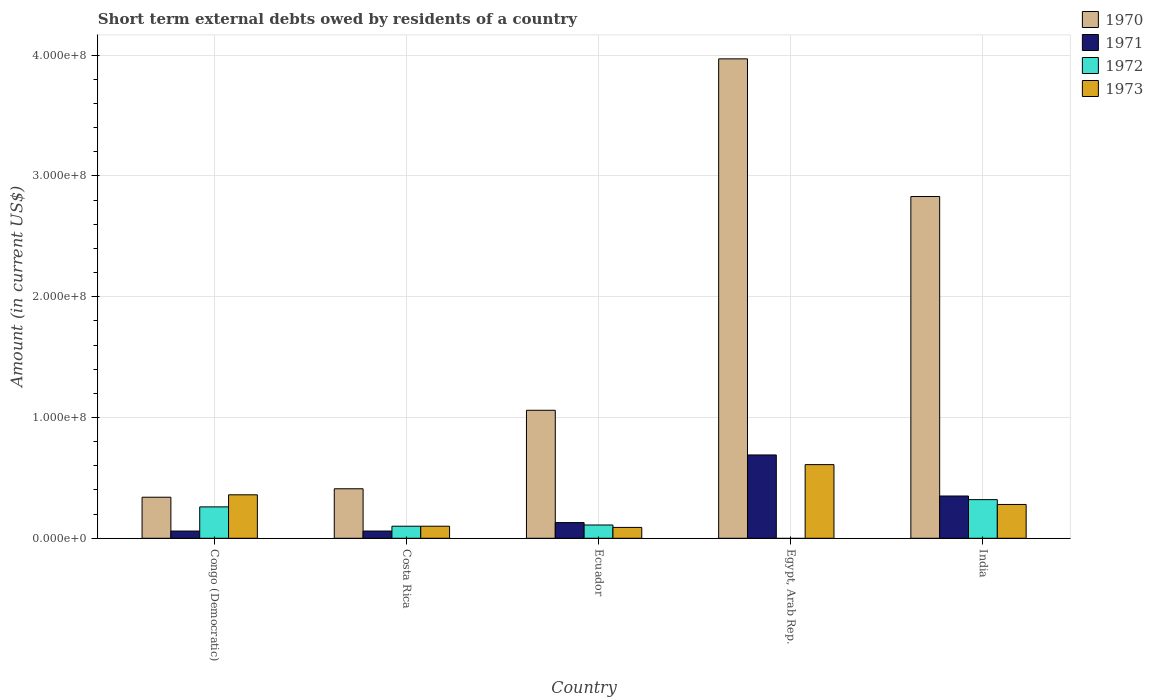How many different coloured bars are there?
Keep it short and to the point. 4. Are the number of bars per tick equal to the number of legend labels?
Give a very brief answer. No. What is the label of the 4th group of bars from the left?
Provide a short and direct response. Egypt, Arab Rep. What is the amount of short-term external debts owed by residents in 1973 in India?
Make the answer very short. 2.80e+07. Across all countries, what is the maximum amount of short-term external debts owed by residents in 1973?
Your answer should be compact. 6.10e+07. Across all countries, what is the minimum amount of short-term external debts owed by residents in 1970?
Keep it short and to the point. 3.40e+07. In which country was the amount of short-term external debts owed by residents in 1971 maximum?
Make the answer very short. Egypt, Arab Rep. What is the total amount of short-term external debts owed by residents in 1970 in the graph?
Your response must be concise. 8.61e+08. What is the difference between the amount of short-term external debts owed by residents in 1970 in Costa Rica and that in Egypt, Arab Rep.?
Provide a short and direct response. -3.56e+08. What is the difference between the amount of short-term external debts owed by residents in 1973 in India and the amount of short-term external debts owed by residents in 1971 in Ecuador?
Keep it short and to the point. 1.50e+07. What is the average amount of short-term external debts owed by residents in 1973 per country?
Your response must be concise. 2.88e+07. In how many countries, is the amount of short-term external debts owed by residents in 1972 greater than 380000000 US$?
Ensure brevity in your answer.  0. What is the ratio of the amount of short-term external debts owed by residents in 1972 in Ecuador to that in India?
Make the answer very short. 0.34. Is the amount of short-term external debts owed by residents in 1970 in Ecuador less than that in Egypt, Arab Rep.?
Your answer should be compact. Yes. What is the difference between the highest and the lowest amount of short-term external debts owed by residents in 1970?
Your answer should be compact. 3.63e+08. Is the sum of the amount of short-term external debts owed by residents in 1973 in Egypt, Arab Rep. and India greater than the maximum amount of short-term external debts owed by residents in 1972 across all countries?
Your answer should be very brief. Yes. Is it the case that in every country, the sum of the amount of short-term external debts owed by residents in 1970 and amount of short-term external debts owed by residents in 1971 is greater than the sum of amount of short-term external debts owed by residents in 1972 and amount of short-term external debts owed by residents in 1973?
Give a very brief answer. Yes. Is it the case that in every country, the sum of the amount of short-term external debts owed by residents in 1973 and amount of short-term external debts owed by residents in 1971 is greater than the amount of short-term external debts owed by residents in 1970?
Offer a terse response. No. How many countries are there in the graph?
Provide a short and direct response. 5. What is the difference between two consecutive major ticks on the Y-axis?
Give a very brief answer. 1.00e+08. Where does the legend appear in the graph?
Offer a very short reply. Top right. How are the legend labels stacked?
Provide a short and direct response. Vertical. What is the title of the graph?
Make the answer very short. Short term external debts owed by residents of a country. Does "2005" appear as one of the legend labels in the graph?
Provide a succinct answer. No. What is the Amount (in current US$) of 1970 in Congo (Democratic)?
Provide a short and direct response. 3.40e+07. What is the Amount (in current US$) of 1971 in Congo (Democratic)?
Offer a terse response. 6.00e+06. What is the Amount (in current US$) of 1972 in Congo (Democratic)?
Provide a succinct answer. 2.60e+07. What is the Amount (in current US$) of 1973 in Congo (Democratic)?
Offer a terse response. 3.60e+07. What is the Amount (in current US$) in 1970 in Costa Rica?
Keep it short and to the point. 4.10e+07. What is the Amount (in current US$) in 1972 in Costa Rica?
Your answer should be compact. 1.00e+07. What is the Amount (in current US$) in 1973 in Costa Rica?
Your answer should be very brief. 1.00e+07. What is the Amount (in current US$) of 1970 in Ecuador?
Your response must be concise. 1.06e+08. What is the Amount (in current US$) in 1971 in Ecuador?
Provide a short and direct response. 1.30e+07. What is the Amount (in current US$) of 1972 in Ecuador?
Your answer should be compact. 1.10e+07. What is the Amount (in current US$) of 1973 in Ecuador?
Your response must be concise. 9.00e+06. What is the Amount (in current US$) in 1970 in Egypt, Arab Rep.?
Your answer should be very brief. 3.97e+08. What is the Amount (in current US$) in 1971 in Egypt, Arab Rep.?
Ensure brevity in your answer.  6.90e+07. What is the Amount (in current US$) in 1973 in Egypt, Arab Rep.?
Offer a terse response. 6.10e+07. What is the Amount (in current US$) of 1970 in India?
Make the answer very short. 2.83e+08. What is the Amount (in current US$) of 1971 in India?
Make the answer very short. 3.50e+07. What is the Amount (in current US$) in 1972 in India?
Provide a succinct answer. 3.20e+07. What is the Amount (in current US$) of 1973 in India?
Your response must be concise. 2.80e+07. Across all countries, what is the maximum Amount (in current US$) of 1970?
Provide a succinct answer. 3.97e+08. Across all countries, what is the maximum Amount (in current US$) of 1971?
Provide a succinct answer. 6.90e+07. Across all countries, what is the maximum Amount (in current US$) of 1972?
Your response must be concise. 3.20e+07. Across all countries, what is the maximum Amount (in current US$) in 1973?
Make the answer very short. 6.10e+07. Across all countries, what is the minimum Amount (in current US$) in 1970?
Give a very brief answer. 3.40e+07. Across all countries, what is the minimum Amount (in current US$) of 1972?
Offer a terse response. 0. Across all countries, what is the minimum Amount (in current US$) of 1973?
Keep it short and to the point. 9.00e+06. What is the total Amount (in current US$) of 1970 in the graph?
Keep it short and to the point. 8.61e+08. What is the total Amount (in current US$) in 1971 in the graph?
Your response must be concise. 1.29e+08. What is the total Amount (in current US$) of 1972 in the graph?
Make the answer very short. 7.90e+07. What is the total Amount (in current US$) of 1973 in the graph?
Offer a very short reply. 1.44e+08. What is the difference between the Amount (in current US$) of 1970 in Congo (Democratic) and that in Costa Rica?
Provide a succinct answer. -7.00e+06. What is the difference between the Amount (in current US$) in 1972 in Congo (Democratic) and that in Costa Rica?
Provide a short and direct response. 1.60e+07. What is the difference between the Amount (in current US$) in 1973 in Congo (Democratic) and that in Costa Rica?
Your answer should be very brief. 2.60e+07. What is the difference between the Amount (in current US$) in 1970 in Congo (Democratic) and that in Ecuador?
Keep it short and to the point. -7.20e+07. What is the difference between the Amount (in current US$) in 1971 in Congo (Democratic) and that in Ecuador?
Give a very brief answer. -7.00e+06. What is the difference between the Amount (in current US$) of 1972 in Congo (Democratic) and that in Ecuador?
Ensure brevity in your answer.  1.50e+07. What is the difference between the Amount (in current US$) of 1973 in Congo (Democratic) and that in Ecuador?
Your answer should be very brief. 2.70e+07. What is the difference between the Amount (in current US$) of 1970 in Congo (Democratic) and that in Egypt, Arab Rep.?
Provide a short and direct response. -3.63e+08. What is the difference between the Amount (in current US$) of 1971 in Congo (Democratic) and that in Egypt, Arab Rep.?
Keep it short and to the point. -6.30e+07. What is the difference between the Amount (in current US$) in 1973 in Congo (Democratic) and that in Egypt, Arab Rep.?
Keep it short and to the point. -2.50e+07. What is the difference between the Amount (in current US$) in 1970 in Congo (Democratic) and that in India?
Your response must be concise. -2.49e+08. What is the difference between the Amount (in current US$) of 1971 in Congo (Democratic) and that in India?
Offer a very short reply. -2.90e+07. What is the difference between the Amount (in current US$) of 1972 in Congo (Democratic) and that in India?
Give a very brief answer. -6.00e+06. What is the difference between the Amount (in current US$) of 1970 in Costa Rica and that in Ecuador?
Offer a very short reply. -6.50e+07. What is the difference between the Amount (in current US$) of 1971 in Costa Rica and that in Ecuador?
Offer a terse response. -7.00e+06. What is the difference between the Amount (in current US$) of 1970 in Costa Rica and that in Egypt, Arab Rep.?
Ensure brevity in your answer.  -3.56e+08. What is the difference between the Amount (in current US$) in 1971 in Costa Rica and that in Egypt, Arab Rep.?
Offer a terse response. -6.30e+07. What is the difference between the Amount (in current US$) in 1973 in Costa Rica and that in Egypt, Arab Rep.?
Make the answer very short. -5.10e+07. What is the difference between the Amount (in current US$) of 1970 in Costa Rica and that in India?
Offer a terse response. -2.42e+08. What is the difference between the Amount (in current US$) in 1971 in Costa Rica and that in India?
Give a very brief answer. -2.90e+07. What is the difference between the Amount (in current US$) in 1972 in Costa Rica and that in India?
Your answer should be compact. -2.20e+07. What is the difference between the Amount (in current US$) of 1973 in Costa Rica and that in India?
Your answer should be compact. -1.80e+07. What is the difference between the Amount (in current US$) in 1970 in Ecuador and that in Egypt, Arab Rep.?
Provide a succinct answer. -2.91e+08. What is the difference between the Amount (in current US$) in 1971 in Ecuador and that in Egypt, Arab Rep.?
Offer a very short reply. -5.60e+07. What is the difference between the Amount (in current US$) in 1973 in Ecuador and that in Egypt, Arab Rep.?
Ensure brevity in your answer.  -5.20e+07. What is the difference between the Amount (in current US$) in 1970 in Ecuador and that in India?
Ensure brevity in your answer.  -1.77e+08. What is the difference between the Amount (in current US$) of 1971 in Ecuador and that in India?
Provide a short and direct response. -2.20e+07. What is the difference between the Amount (in current US$) in 1972 in Ecuador and that in India?
Provide a short and direct response. -2.10e+07. What is the difference between the Amount (in current US$) in 1973 in Ecuador and that in India?
Offer a terse response. -1.90e+07. What is the difference between the Amount (in current US$) of 1970 in Egypt, Arab Rep. and that in India?
Make the answer very short. 1.14e+08. What is the difference between the Amount (in current US$) in 1971 in Egypt, Arab Rep. and that in India?
Provide a short and direct response. 3.40e+07. What is the difference between the Amount (in current US$) in 1973 in Egypt, Arab Rep. and that in India?
Provide a short and direct response. 3.30e+07. What is the difference between the Amount (in current US$) of 1970 in Congo (Democratic) and the Amount (in current US$) of 1971 in Costa Rica?
Your response must be concise. 2.80e+07. What is the difference between the Amount (in current US$) in 1970 in Congo (Democratic) and the Amount (in current US$) in 1972 in Costa Rica?
Provide a short and direct response. 2.40e+07. What is the difference between the Amount (in current US$) of 1970 in Congo (Democratic) and the Amount (in current US$) of 1973 in Costa Rica?
Give a very brief answer. 2.40e+07. What is the difference between the Amount (in current US$) in 1971 in Congo (Democratic) and the Amount (in current US$) in 1972 in Costa Rica?
Make the answer very short. -4.00e+06. What is the difference between the Amount (in current US$) in 1972 in Congo (Democratic) and the Amount (in current US$) in 1973 in Costa Rica?
Provide a succinct answer. 1.60e+07. What is the difference between the Amount (in current US$) in 1970 in Congo (Democratic) and the Amount (in current US$) in 1971 in Ecuador?
Ensure brevity in your answer.  2.10e+07. What is the difference between the Amount (in current US$) in 1970 in Congo (Democratic) and the Amount (in current US$) in 1972 in Ecuador?
Offer a terse response. 2.30e+07. What is the difference between the Amount (in current US$) of 1970 in Congo (Democratic) and the Amount (in current US$) of 1973 in Ecuador?
Provide a succinct answer. 2.50e+07. What is the difference between the Amount (in current US$) of 1971 in Congo (Democratic) and the Amount (in current US$) of 1972 in Ecuador?
Your response must be concise. -5.00e+06. What is the difference between the Amount (in current US$) of 1972 in Congo (Democratic) and the Amount (in current US$) of 1973 in Ecuador?
Make the answer very short. 1.70e+07. What is the difference between the Amount (in current US$) of 1970 in Congo (Democratic) and the Amount (in current US$) of 1971 in Egypt, Arab Rep.?
Offer a very short reply. -3.50e+07. What is the difference between the Amount (in current US$) in 1970 in Congo (Democratic) and the Amount (in current US$) in 1973 in Egypt, Arab Rep.?
Your response must be concise. -2.70e+07. What is the difference between the Amount (in current US$) of 1971 in Congo (Democratic) and the Amount (in current US$) of 1973 in Egypt, Arab Rep.?
Provide a short and direct response. -5.50e+07. What is the difference between the Amount (in current US$) in 1972 in Congo (Democratic) and the Amount (in current US$) in 1973 in Egypt, Arab Rep.?
Make the answer very short. -3.50e+07. What is the difference between the Amount (in current US$) in 1970 in Congo (Democratic) and the Amount (in current US$) in 1971 in India?
Keep it short and to the point. -1.00e+06. What is the difference between the Amount (in current US$) in 1970 in Congo (Democratic) and the Amount (in current US$) in 1972 in India?
Your response must be concise. 2.00e+06. What is the difference between the Amount (in current US$) in 1971 in Congo (Democratic) and the Amount (in current US$) in 1972 in India?
Offer a very short reply. -2.60e+07. What is the difference between the Amount (in current US$) in 1971 in Congo (Democratic) and the Amount (in current US$) in 1973 in India?
Provide a succinct answer. -2.20e+07. What is the difference between the Amount (in current US$) in 1970 in Costa Rica and the Amount (in current US$) in 1971 in Ecuador?
Provide a short and direct response. 2.80e+07. What is the difference between the Amount (in current US$) of 1970 in Costa Rica and the Amount (in current US$) of 1972 in Ecuador?
Give a very brief answer. 3.00e+07. What is the difference between the Amount (in current US$) of 1970 in Costa Rica and the Amount (in current US$) of 1973 in Ecuador?
Your answer should be compact. 3.20e+07. What is the difference between the Amount (in current US$) of 1971 in Costa Rica and the Amount (in current US$) of 1972 in Ecuador?
Give a very brief answer. -5.00e+06. What is the difference between the Amount (in current US$) in 1972 in Costa Rica and the Amount (in current US$) in 1973 in Ecuador?
Make the answer very short. 1.00e+06. What is the difference between the Amount (in current US$) of 1970 in Costa Rica and the Amount (in current US$) of 1971 in Egypt, Arab Rep.?
Offer a very short reply. -2.80e+07. What is the difference between the Amount (in current US$) of 1970 in Costa Rica and the Amount (in current US$) of 1973 in Egypt, Arab Rep.?
Keep it short and to the point. -2.00e+07. What is the difference between the Amount (in current US$) in 1971 in Costa Rica and the Amount (in current US$) in 1973 in Egypt, Arab Rep.?
Provide a succinct answer. -5.50e+07. What is the difference between the Amount (in current US$) in 1972 in Costa Rica and the Amount (in current US$) in 1973 in Egypt, Arab Rep.?
Give a very brief answer. -5.10e+07. What is the difference between the Amount (in current US$) of 1970 in Costa Rica and the Amount (in current US$) of 1971 in India?
Offer a terse response. 6.00e+06. What is the difference between the Amount (in current US$) of 1970 in Costa Rica and the Amount (in current US$) of 1972 in India?
Your answer should be very brief. 9.00e+06. What is the difference between the Amount (in current US$) in 1970 in Costa Rica and the Amount (in current US$) in 1973 in India?
Offer a terse response. 1.30e+07. What is the difference between the Amount (in current US$) in 1971 in Costa Rica and the Amount (in current US$) in 1972 in India?
Your response must be concise. -2.60e+07. What is the difference between the Amount (in current US$) in 1971 in Costa Rica and the Amount (in current US$) in 1973 in India?
Your answer should be compact. -2.20e+07. What is the difference between the Amount (in current US$) in 1972 in Costa Rica and the Amount (in current US$) in 1973 in India?
Your answer should be compact. -1.80e+07. What is the difference between the Amount (in current US$) in 1970 in Ecuador and the Amount (in current US$) in 1971 in Egypt, Arab Rep.?
Give a very brief answer. 3.70e+07. What is the difference between the Amount (in current US$) of 1970 in Ecuador and the Amount (in current US$) of 1973 in Egypt, Arab Rep.?
Your response must be concise. 4.50e+07. What is the difference between the Amount (in current US$) in 1971 in Ecuador and the Amount (in current US$) in 1973 in Egypt, Arab Rep.?
Make the answer very short. -4.80e+07. What is the difference between the Amount (in current US$) of 1972 in Ecuador and the Amount (in current US$) of 1973 in Egypt, Arab Rep.?
Your response must be concise. -5.00e+07. What is the difference between the Amount (in current US$) in 1970 in Ecuador and the Amount (in current US$) in 1971 in India?
Provide a short and direct response. 7.10e+07. What is the difference between the Amount (in current US$) in 1970 in Ecuador and the Amount (in current US$) in 1972 in India?
Offer a very short reply. 7.40e+07. What is the difference between the Amount (in current US$) of 1970 in Ecuador and the Amount (in current US$) of 1973 in India?
Offer a very short reply. 7.80e+07. What is the difference between the Amount (in current US$) in 1971 in Ecuador and the Amount (in current US$) in 1972 in India?
Give a very brief answer. -1.90e+07. What is the difference between the Amount (in current US$) in 1971 in Ecuador and the Amount (in current US$) in 1973 in India?
Offer a terse response. -1.50e+07. What is the difference between the Amount (in current US$) of 1972 in Ecuador and the Amount (in current US$) of 1973 in India?
Provide a short and direct response. -1.70e+07. What is the difference between the Amount (in current US$) of 1970 in Egypt, Arab Rep. and the Amount (in current US$) of 1971 in India?
Offer a terse response. 3.62e+08. What is the difference between the Amount (in current US$) of 1970 in Egypt, Arab Rep. and the Amount (in current US$) of 1972 in India?
Your answer should be very brief. 3.65e+08. What is the difference between the Amount (in current US$) in 1970 in Egypt, Arab Rep. and the Amount (in current US$) in 1973 in India?
Keep it short and to the point. 3.69e+08. What is the difference between the Amount (in current US$) in 1971 in Egypt, Arab Rep. and the Amount (in current US$) in 1972 in India?
Make the answer very short. 3.70e+07. What is the difference between the Amount (in current US$) in 1971 in Egypt, Arab Rep. and the Amount (in current US$) in 1973 in India?
Offer a very short reply. 4.10e+07. What is the average Amount (in current US$) in 1970 per country?
Your answer should be compact. 1.72e+08. What is the average Amount (in current US$) in 1971 per country?
Provide a succinct answer. 2.58e+07. What is the average Amount (in current US$) in 1972 per country?
Ensure brevity in your answer.  1.58e+07. What is the average Amount (in current US$) in 1973 per country?
Your response must be concise. 2.88e+07. What is the difference between the Amount (in current US$) of 1970 and Amount (in current US$) of 1971 in Congo (Democratic)?
Your answer should be compact. 2.80e+07. What is the difference between the Amount (in current US$) of 1970 and Amount (in current US$) of 1973 in Congo (Democratic)?
Give a very brief answer. -2.00e+06. What is the difference between the Amount (in current US$) in 1971 and Amount (in current US$) in 1972 in Congo (Democratic)?
Your response must be concise. -2.00e+07. What is the difference between the Amount (in current US$) in 1971 and Amount (in current US$) in 1973 in Congo (Democratic)?
Ensure brevity in your answer.  -3.00e+07. What is the difference between the Amount (in current US$) of 1972 and Amount (in current US$) of 1973 in Congo (Democratic)?
Offer a terse response. -1.00e+07. What is the difference between the Amount (in current US$) in 1970 and Amount (in current US$) in 1971 in Costa Rica?
Provide a short and direct response. 3.50e+07. What is the difference between the Amount (in current US$) of 1970 and Amount (in current US$) of 1972 in Costa Rica?
Offer a very short reply. 3.10e+07. What is the difference between the Amount (in current US$) in 1970 and Amount (in current US$) in 1973 in Costa Rica?
Offer a terse response. 3.10e+07. What is the difference between the Amount (in current US$) in 1971 and Amount (in current US$) in 1972 in Costa Rica?
Make the answer very short. -4.00e+06. What is the difference between the Amount (in current US$) in 1970 and Amount (in current US$) in 1971 in Ecuador?
Your answer should be compact. 9.30e+07. What is the difference between the Amount (in current US$) in 1970 and Amount (in current US$) in 1972 in Ecuador?
Your answer should be compact. 9.50e+07. What is the difference between the Amount (in current US$) of 1970 and Amount (in current US$) of 1973 in Ecuador?
Your answer should be very brief. 9.70e+07. What is the difference between the Amount (in current US$) in 1971 and Amount (in current US$) in 1973 in Ecuador?
Offer a very short reply. 4.00e+06. What is the difference between the Amount (in current US$) of 1970 and Amount (in current US$) of 1971 in Egypt, Arab Rep.?
Give a very brief answer. 3.28e+08. What is the difference between the Amount (in current US$) of 1970 and Amount (in current US$) of 1973 in Egypt, Arab Rep.?
Provide a succinct answer. 3.36e+08. What is the difference between the Amount (in current US$) in 1971 and Amount (in current US$) in 1973 in Egypt, Arab Rep.?
Ensure brevity in your answer.  8.00e+06. What is the difference between the Amount (in current US$) of 1970 and Amount (in current US$) of 1971 in India?
Your response must be concise. 2.48e+08. What is the difference between the Amount (in current US$) of 1970 and Amount (in current US$) of 1972 in India?
Offer a very short reply. 2.51e+08. What is the difference between the Amount (in current US$) in 1970 and Amount (in current US$) in 1973 in India?
Make the answer very short. 2.55e+08. What is the difference between the Amount (in current US$) of 1971 and Amount (in current US$) of 1973 in India?
Provide a short and direct response. 7.00e+06. What is the difference between the Amount (in current US$) of 1972 and Amount (in current US$) of 1973 in India?
Your answer should be compact. 4.00e+06. What is the ratio of the Amount (in current US$) in 1970 in Congo (Democratic) to that in Costa Rica?
Make the answer very short. 0.83. What is the ratio of the Amount (in current US$) of 1973 in Congo (Democratic) to that in Costa Rica?
Provide a succinct answer. 3.6. What is the ratio of the Amount (in current US$) in 1970 in Congo (Democratic) to that in Ecuador?
Make the answer very short. 0.32. What is the ratio of the Amount (in current US$) in 1971 in Congo (Democratic) to that in Ecuador?
Keep it short and to the point. 0.46. What is the ratio of the Amount (in current US$) of 1972 in Congo (Democratic) to that in Ecuador?
Make the answer very short. 2.36. What is the ratio of the Amount (in current US$) in 1973 in Congo (Democratic) to that in Ecuador?
Make the answer very short. 4. What is the ratio of the Amount (in current US$) of 1970 in Congo (Democratic) to that in Egypt, Arab Rep.?
Give a very brief answer. 0.09. What is the ratio of the Amount (in current US$) of 1971 in Congo (Democratic) to that in Egypt, Arab Rep.?
Your response must be concise. 0.09. What is the ratio of the Amount (in current US$) of 1973 in Congo (Democratic) to that in Egypt, Arab Rep.?
Provide a succinct answer. 0.59. What is the ratio of the Amount (in current US$) in 1970 in Congo (Democratic) to that in India?
Offer a very short reply. 0.12. What is the ratio of the Amount (in current US$) in 1971 in Congo (Democratic) to that in India?
Keep it short and to the point. 0.17. What is the ratio of the Amount (in current US$) of 1972 in Congo (Democratic) to that in India?
Your answer should be very brief. 0.81. What is the ratio of the Amount (in current US$) in 1973 in Congo (Democratic) to that in India?
Your response must be concise. 1.29. What is the ratio of the Amount (in current US$) in 1970 in Costa Rica to that in Ecuador?
Offer a very short reply. 0.39. What is the ratio of the Amount (in current US$) in 1971 in Costa Rica to that in Ecuador?
Make the answer very short. 0.46. What is the ratio of the Amount (in current US$) of 1973 in Costa Rica to that in Ecuador?
Your answer should be compact. 1.11. What is the ratio of the Amount (in current US$) in 1970 in Costa Rica to that in Egypt, Arab Rep.?
Your answer should be compact. 0.1. What is the ratio of the Amount (in current US$) in 1971 in Costa Rica to that in Egypt, Arab Rep.?
Offer a very short reply. 0.09. What is the ratio of the Amount (in current US$) in 1973 in Costa Rica to that in Egypt, Arab Rep.?
Offer a terse response. 0.16. What is the ratio of the Amount (in current US$) in 1970 in Costa Rica to that in India?
Ensure brevity in your answer.  0.14. What is the ratio of the Amount (in current US$) of 1971 in Costa Rica to that in India?
Provide a succinct answer. 0.17. What is the ratio of the Amount (in current US$) in 1972 in Costa Rica to that in India?
Provide a short and direct response. 0.31. What is the ratio of the Amount (in current US$) in 1973 in Costa Rica to that in India?
Keep it short and to the point. 0.36. What is the ratio of the Amount (in current US$) of 1970 in Ecuador to that in Egypt, Arab Rep.?
Your response must be concise. 0.27. What is the ratio of the Amount (in current US$) of 1971 in Ecuador to that in Egypt, Arab Rep.?
Give a very brief answer. 0.19. What is the ratio of the Amount (in current US$) of 1973 in Ecuador to that in Egypt, Arab Rep.?
Your answer should be compact. 0.15. What is the ratio of the Amount (in current US$) in 1970 in Ecuador to that in India?
Make the answer very short. 0.37. What is the ratio of the Amount (in current US$) of 1971 in Ecuador to that in India?
Make the answer very short. 0.37. What is the ratio of the Amount (in current US$) of 1972 in Ecuador to that in India?
Provide a succinct answer. 0.34. What is the ratio of the Amount (in current US$) in 1973 in Ecuador to that in India?
Ensure brevity in your answer.  0.32. What is the ratio of the Amount (in current US$) of 1970 in Egypt, Arab Rep. to that in India?
Provide a succinct answer. 1.4. What is the ratio of the Amount (in current US$) of 1971 in Egypt, Arab Rep. to that in India?
Provide a succinct answer. 1.97. What is the ratio of the Amount (in current US$) of 1973 in Egypt, Arab Rep. to that in India?
Give a very brief answer. 2.18. What is the difference between the highest and the second highest Amount (in current US$) in 1970?
Your answer should be compact. 1.14e+08. What is the difference between the highest and the second highest Amount (in current US$) in 1971?
Offer a terse response. 3.40e+07. What is the difference between the highest and the second highest Amount (in current US$) in 1973?
Offer a terse response. 2.50e+07. What is the difference between the highest and the lowest Amount (in current US$) in 1970?
Your response must be concise. 3.63e+08. What is the difference between the highest and the lowest Amount (in current US$) in 1971?
Your response must be concise. 6.30e+07. What is the difference between the highest and the lowest Amount (in current US$) of 1972?
Offer a terse response. 3.20e+07. What is the difference between the highest and the lowest Amount (in current US$) in 1973?
Provide a short and direct response. 5.20e+07. 